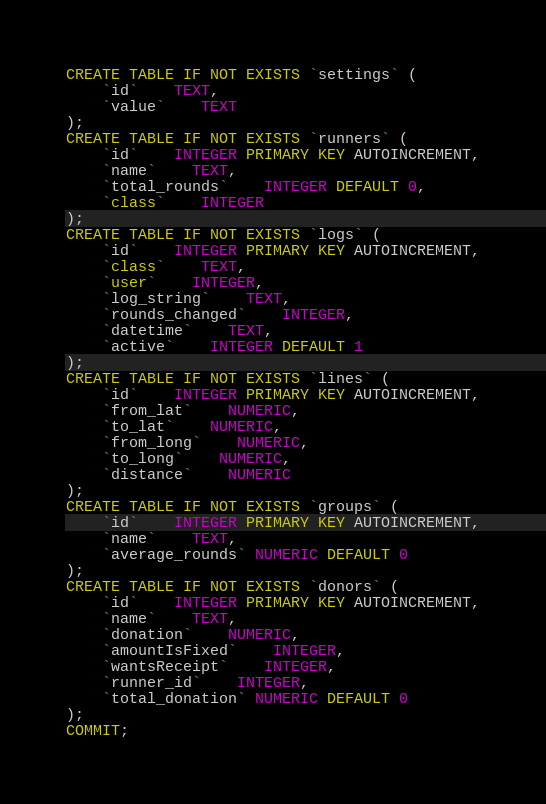Convert code to text. <code><loc_0><loc_0><loc_500><loc_500><_SQL_>CREATE TABLE IF NOT EXISTS `settings` (
	`id`	TEXT,
	`value`	TEXT
);
CREATE TABLE IF NOT EXISTS `runners` (
	`id`	INTEGER PRIMARY KEY AUTOINCREMENT,
	`name`	TEXT,
	`total_rounds`	INTEGER DEFAULT 0,
	`class`	INTEGER
);
CREATE TABLE IF NOT EXISTS `logs` (
	`id`	INTEGER PRIMARY KEY AUTOINCREMENT,
	`class`	TEXT,
	`user`	INTEGER,
	`log_string`	TEXT,
	`rounds_changed`	INTEGER,
	`datetime`	TEXT,
	`active`	INTEGER DEFAULT 1
);
CREATE TABLE IF NOT EXISTS `lines` (
	`id`	INTEGER PRIMARY KEY AUTOINCREMENT,
	`from_lat`	NUMERIC,
	`to_lat`	NUMERIC,
	`from_long`	NUMERIC,
	`to_long`	NUMERIC,
	`distance`	NUMERIC
);
CREATE TABLE IF NOT EXISTS `groups` (
	`id`	INTEGER PRIMARY KEY AUTOINCREMENT,
	`name`	TEXT,
	`average_rounds` NUMERIC DEFAULT 0
);
CREATE TABLE IF NOT EXISTS `donors` (
	`id`	INTEGER PRIMARY KEY AUTOINCREMENT,
	`name`	TEXT,
	`donation`	NUMERIC,
	`amountIsFixed`	INTEGER,
	`wantsReceipt`	INTEGER,
	`runner_id`	INTEGER,
	`total_donation` NUMERIC DEFAULT 0
);
COMMIT;
</code> 